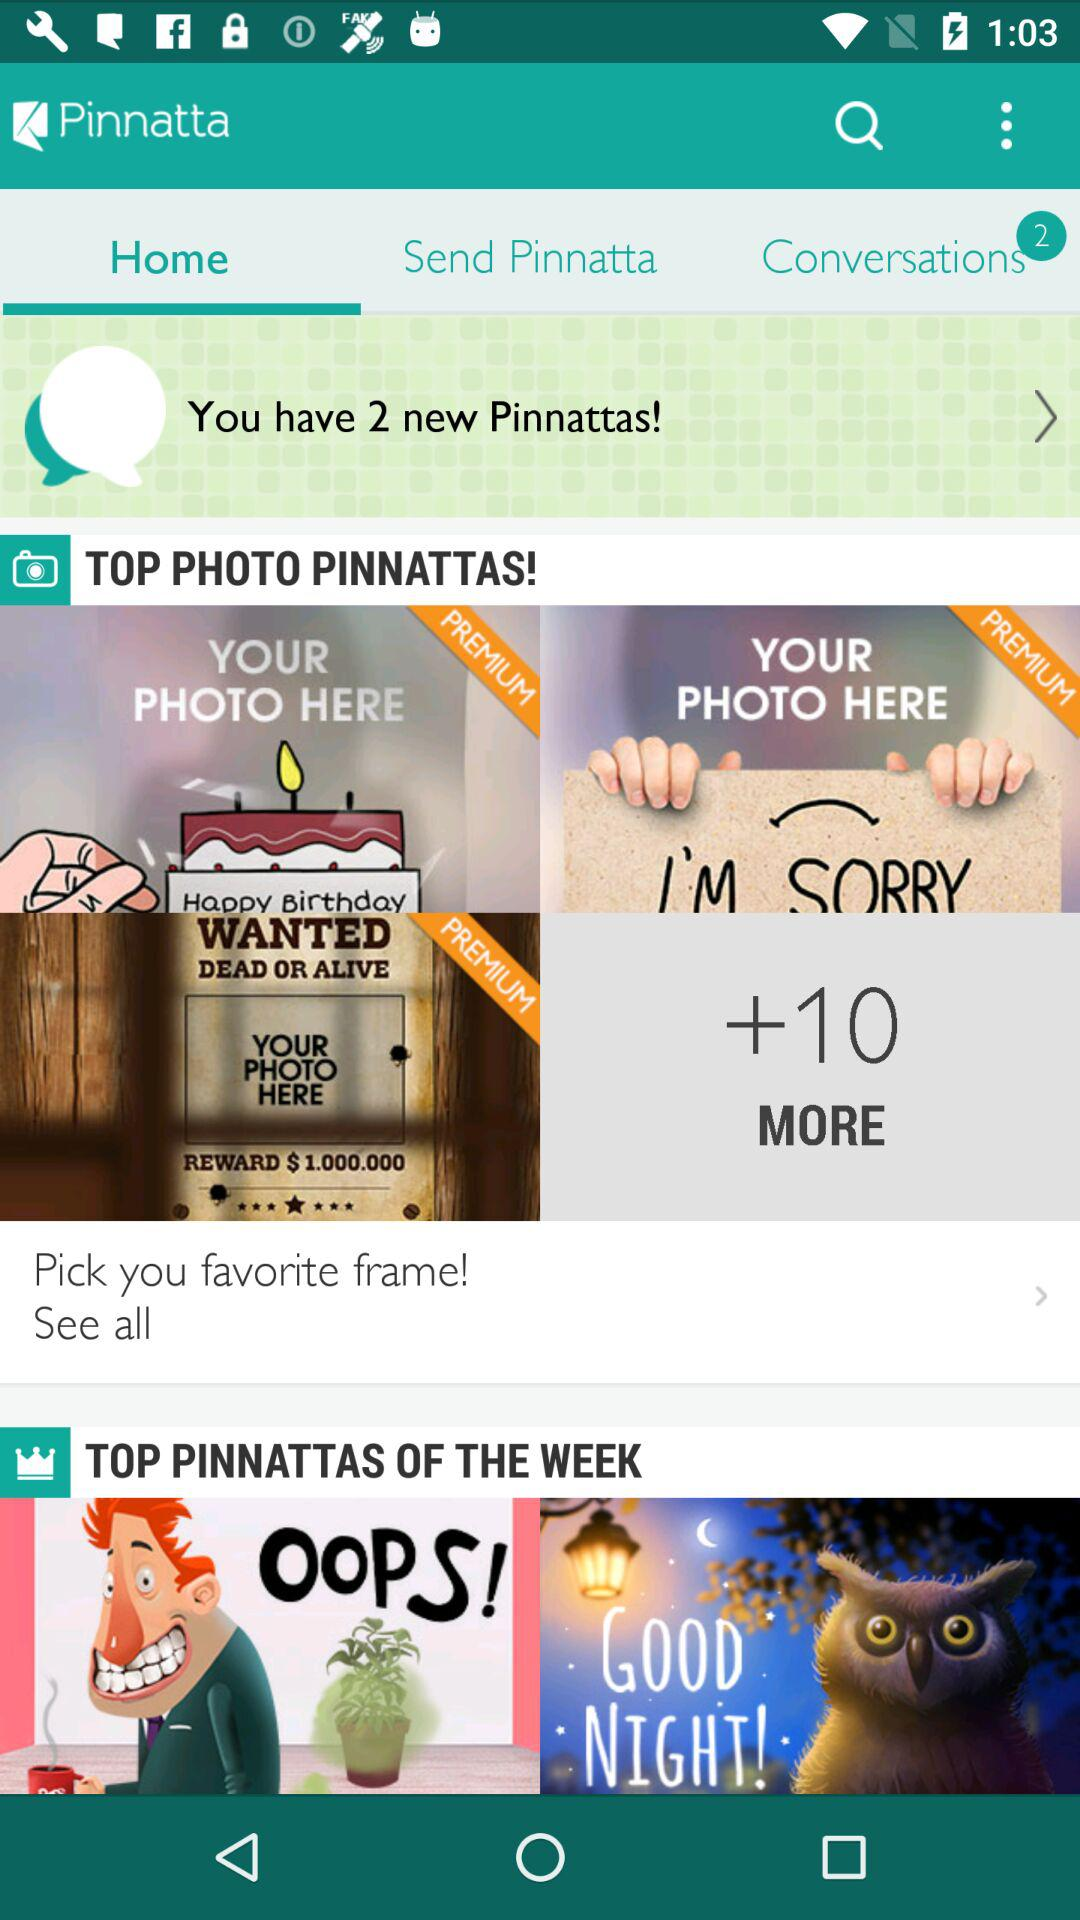What is the application name? The application name is "Pinnatta". 